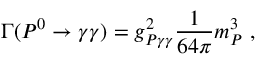Convert formula to latex. <formula><loc_0><loc_0><loc_500><loc_500>\Gamma ( P ^ { 0 } \rightarrow \gamma \gamma ) = g _ { P \gamma \gamma } ^ { 2 } \frac { 1 } { 6 4 \pi } m _ { P } ^ { 3 } \ ,</formula> 